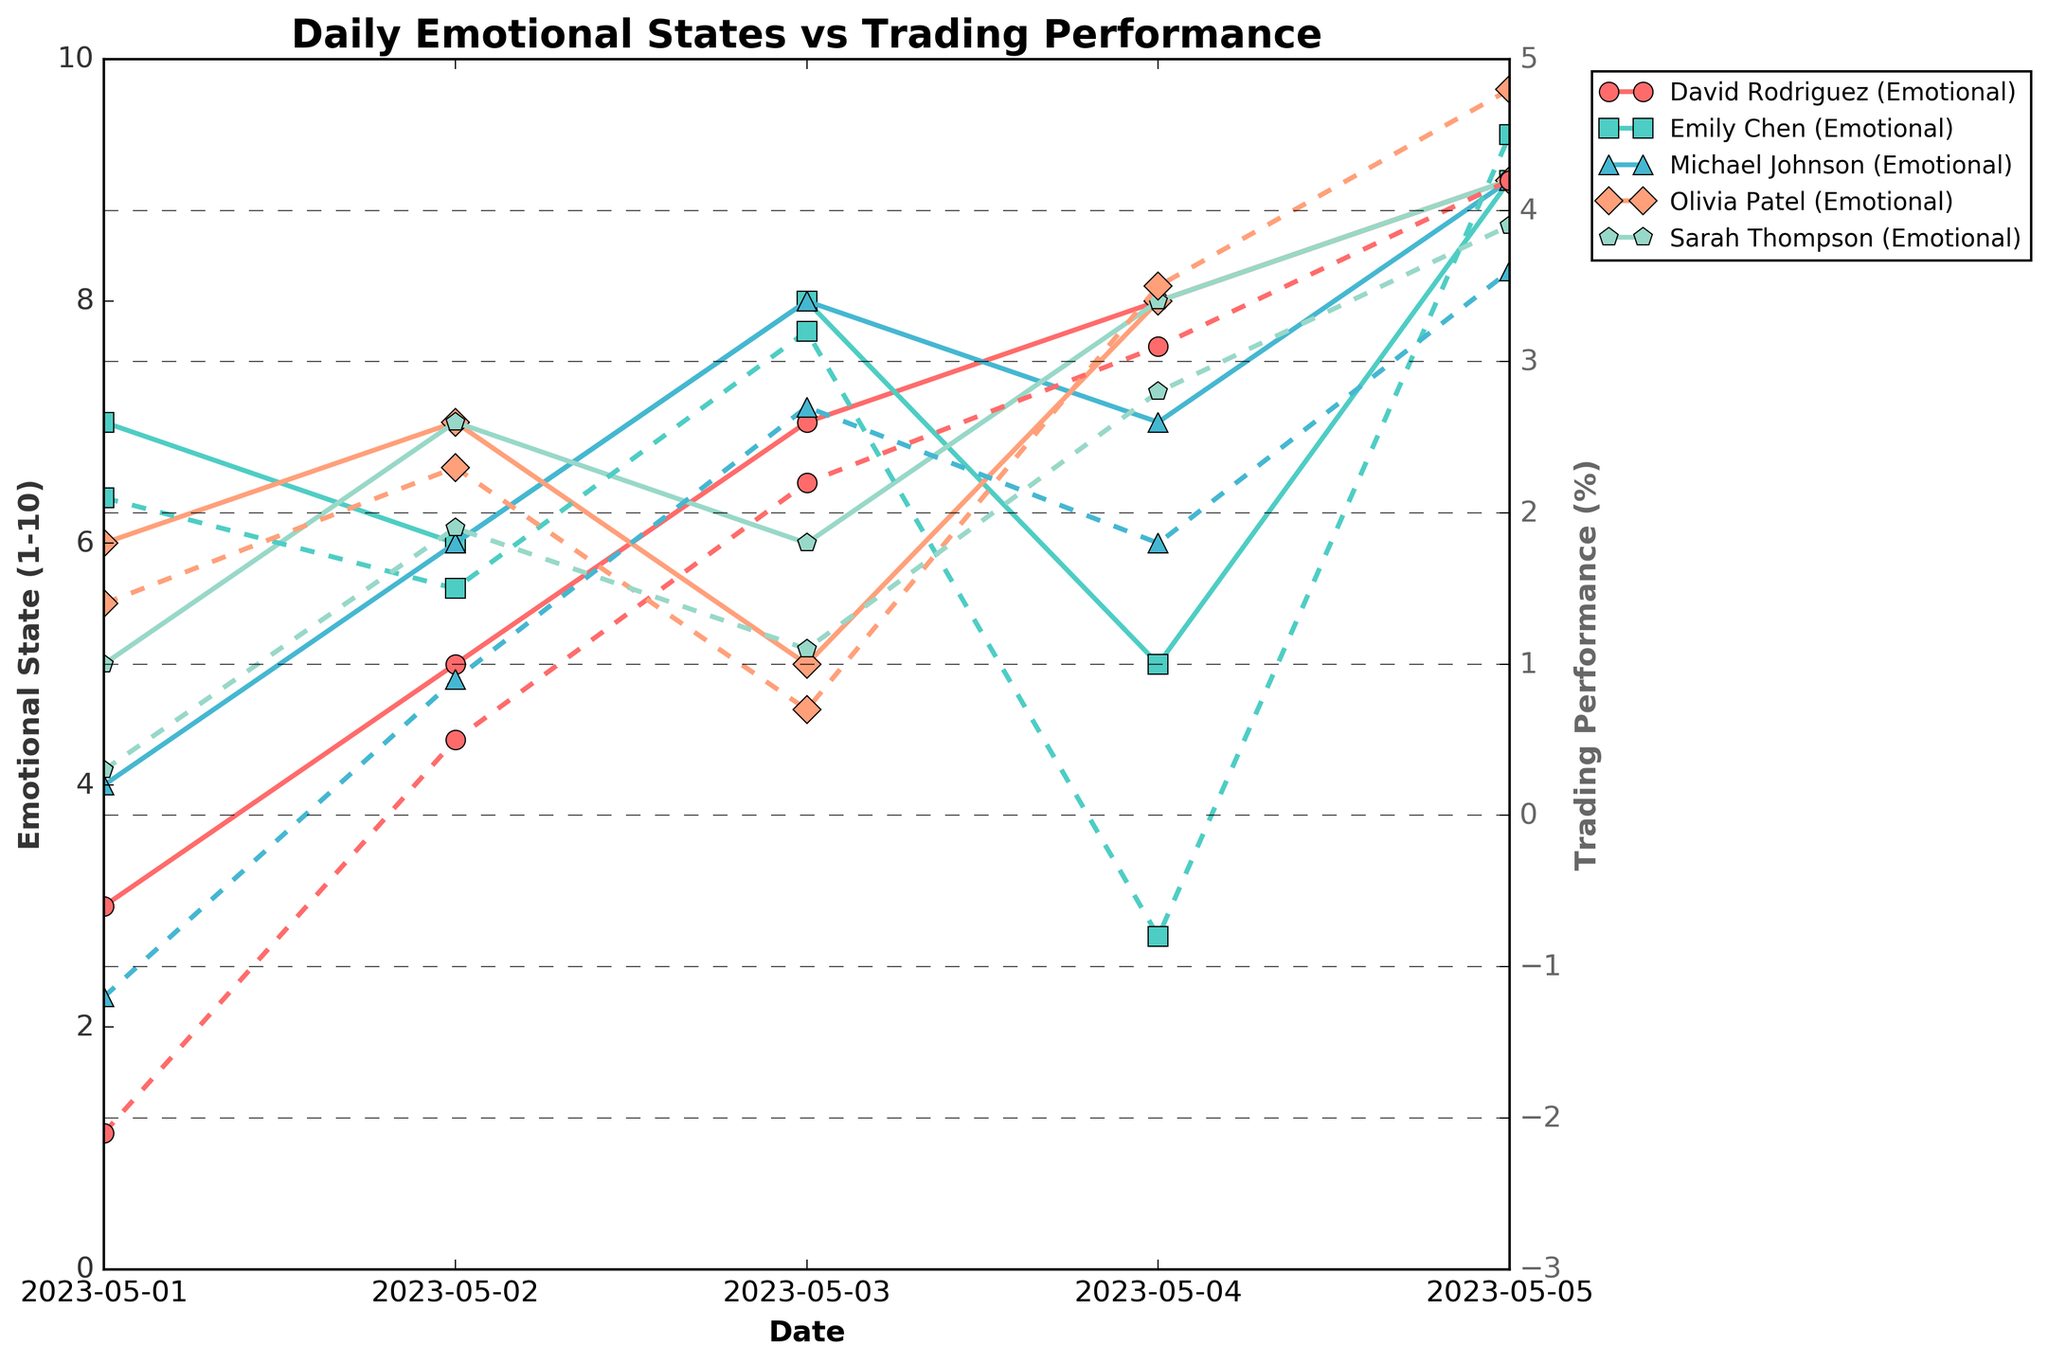What was Emily Chen's emotional state on May 3rd, and how does it compare to her trading performance on the same day? Emily Chen's emotional state on May 3rd can be found in her plot line for emotional state, marked with a specific marker. On May 3rd, her emotional state was 8. Her trading performance on the same day can be found in the same marker but with a dashed line, which was 3.2%. Therefore, her emotional state is higher than her trading performance, which is also positive.
Answer: Emotional state: 8, Trading performance: 3.2% Which trader had the highest trading performance on May 5th, and what was their emotional state on that day? By examining the plot lines for trading performance on May 5th, marked by specific markers, Olivia Patel had the highest trading performance of 4.8%. Her emotional state on that day can be found in the solid line, which was 9.
Answer: Olivia Patel, Emotional state: 9 Compute the average emotional state of David Rodriguez over the five days shown. David Rodriguez's emotional states over the five days are 3, 5, 7, 8, and 9. Sum these values to get 32, then divide by the number of days (5) to get the average. 32 / 5 = 6.4.
Answer: 6.4 Which trader had a negative trading performance on any given day, and what were their emotional states and trading performance on that day? Michael Johnson on May 1st with an emotional state of 4 and trading performance of -1.2. Emily Chen on May 4th with an emotional state of 5 and trading performance of -0.8. David Rodriguez on May 1st with an emotional state of 3 and trading performance of -2.1.
Answer: Michael Johnson: 4, -1.2; Emily Chen: 5, -0.8; David Rodriguez: 3, -2.1 Between Emily Chen and Sarah Thompson, who showed a higher overall improvement in trading performance from May 1st to May 5th? Calculate the difference in trading performance for both traders from May 1st to May 5th. For Emily Chen, it's 4.5 - 2.1 = 2.4. For Sarah Thompson, it's 3.9 - 0.3 = 3.6. Therefore, Sarah Thompson showed a higher improvement.
Answer: Sarah Thompson On which specific days do all traders have an emotional state of 9, and what is the average trading performance across all traders on that day? All traders have an emotional state of 9 on May 5th. Adding their trading performances on that day: 4.5 (Emily Chen) + 3.6 (Michael Johnson) + 3.9 (Sarah Thompson) + 4.2 (David Rodriguez) + 4.8 (Olivia Patel) equals 21. Divide by the number of traders (5) to get the average: 21 / 5 = 4.2.
Answer: May 5th, 4.2 What general trend can be observed between emotional state and trading performance across all traders? Observing the lines in the figure, it can be seen that higher emotional states generally correspond to higher trading performances for all traders. This suggests a correlation where feeling emotionally better might contribute to better trading outcomes.
Answer: Positive Correlation 